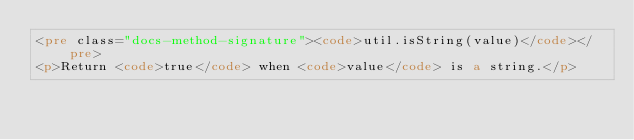<code> <loc_0><loc_0><loc_500><loc_500><_HTML_><pre class="docs-method-signature"><code>util.isString(value)</code></pre>
<p>Return <code>true</code> when <code>value</code> is a string.</p>
</code> 